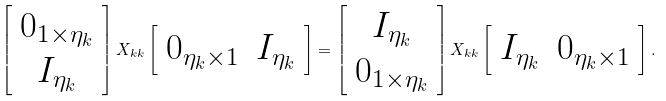<formula> <loc_0><loc_0><loc_500><loc_500>\left [ \begin{array} { c } 0 _ { 1 \times \eta _ { k } } \\ I _ { \eta _ { k } } \end{array} \right ] X _ { k k } \left [ \begin{array} { c c } 0 _ { \eta _ { k } \times 1 } & I _ { \eta _ { k } } \end{array} \right ] = \left [ \begin{array} { c } I _ { \eta _ { k } } \\ 0 _ { 1 \times \eta _ { k } } \end{array} \right ] X _ { k k } \left [ \begin{array} { c c } I _ { \eta _ { k } } & 0 _ { \eta _ { k } \times 1 } \end{array} \right ] .</formula> 